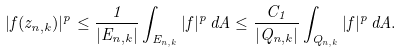Convert formula to latex. <formula><loc_0><loc_0><loc_500><loc_500>| f ( z _ { n , k } ) | ^ { p } \leq \frac { 1 } { | E _ { n , k } | } \int _ { E _ { n , k } } | f | ^ { p } \, d A \leq \frac { C _ { 1 } } { | Q _ { n , k } | } \int _ { Q _ { n , k } } | f | ^ { p } \, d A .</formula> 